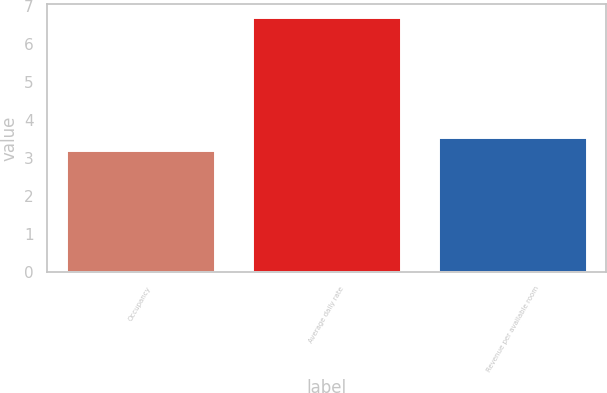Convert chart to OTSL. <chart><loc_0><loc_0><loc_500><loc_500><bar_chart><fcel>Occupancy<fcel>Average daily rate<fcel>Revenue per available room<nl><fcel>3.2<fcel>6.7<fcel>3.55<nl></chart> 